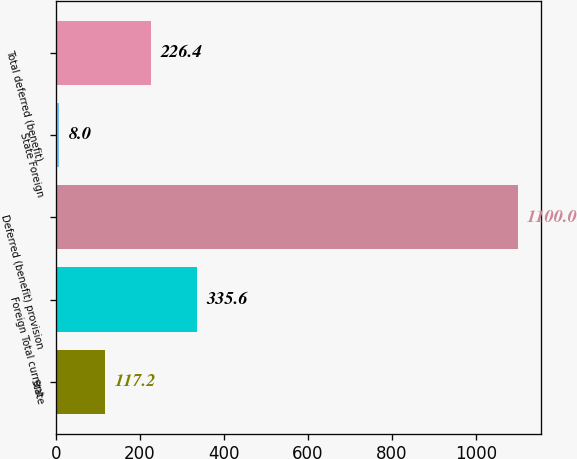<chart> <loc_0><loc_0><loc_500><loc_500><bar_chart><fcel>State<fcel>Foreign Total current<fcel>Deferred (benefit) provision<fcel>State Foreign<fcel>Total deferred (benefit)<nl><fcel>117.2<fcel>335.6<fcel>1100<fcel>8<fcel>226.4<nl></chart> 